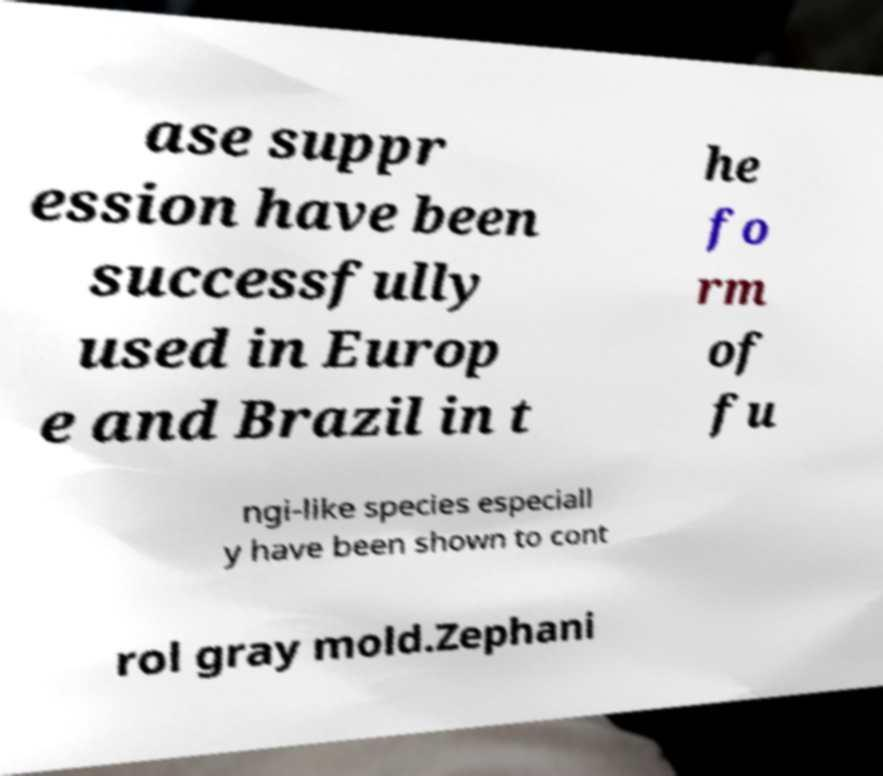Could you extract and type out the text from this image? ase suppr ession have been successfully used in Europ e and Brazil in t he fo rm of fu ngi-like species especiall y have been shown to cont rol gray mold.Zephani 